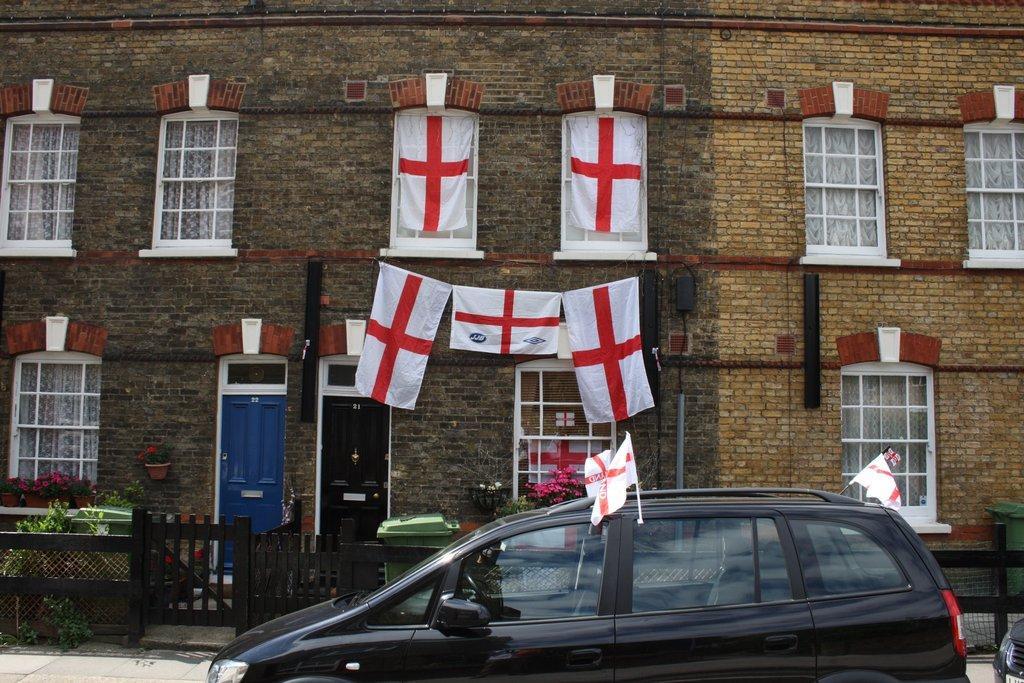In one or two sentences, can you explain what this image depicts? In this image in the front there is a car which is black in colour and on the car there are flags. In the background there is a building and there are windows and there are flags hanging on the building and in front of the building there is a fence which is black in colour and there are plants and there are bins which are green in colour. 